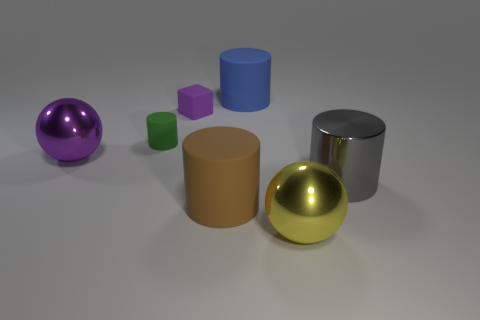Subtract 1 cylinders. How many cylinders are left? 3 Add 2 green matte cylinders. How many objects exist? 9 Subtract all cylinders. How many objects are left? 3 Subtract 0 cyan cylinders. How many objects are left? 7 Subtract all brown metallic cylinders. Subtract all large purple things. How many objects are left? 6 Add 7 matte cylinders. How many matte cylinders are left? 10 Add 1 big brown rubber cylinders. How many big brown rubber cylinders exist? 2 